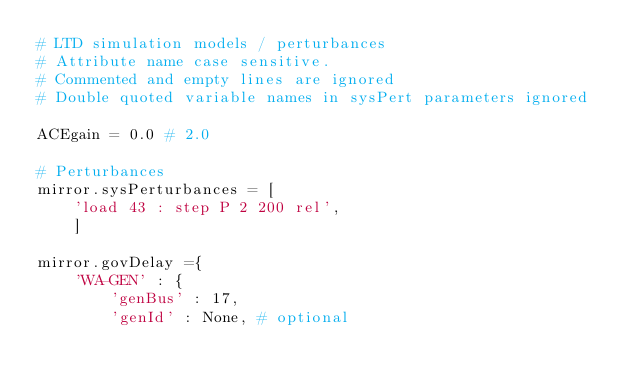Convert code to text. <code><loc_0><loc_0><loc_500><loc_500><_Python_># LTD simulation models / perturbances
# Attribute name case sensitive.
# Commented and empty lines are ignored
# Double quoted variable names in sysPert parameters ignored

ACEgain = 0.0 # 2.0

# Perturbances
mirror.sysPerturbances = [
    'load 43 : step P 2 200 rel',
    ]

mirror.govDelay ={
    'WA-GEN' : {
        'genBus' : 17,
        'genId' : None, # optional</code> 